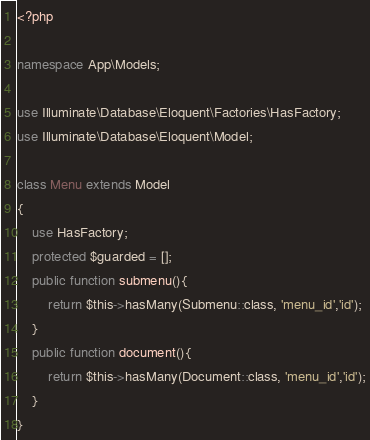<code> <loc_0><loc_0><loc_500><loc_500><_PHP_><?php

namespace App\Models;

use Illuminate\Database\Eloquent\Factories\HasFactory;
use Illuminate\Database\Eloquent\Model;

class Menu extends Model
{
    use HasFactory;
    protected $guarded = [];
    public function submenu(){
        return $this->hasMany(Submenu::class, 'menu_id','id');
    }
    public function document(){
        return $this->hasMany(Document::class, 'menu_id','id');
    }
}
</code> 